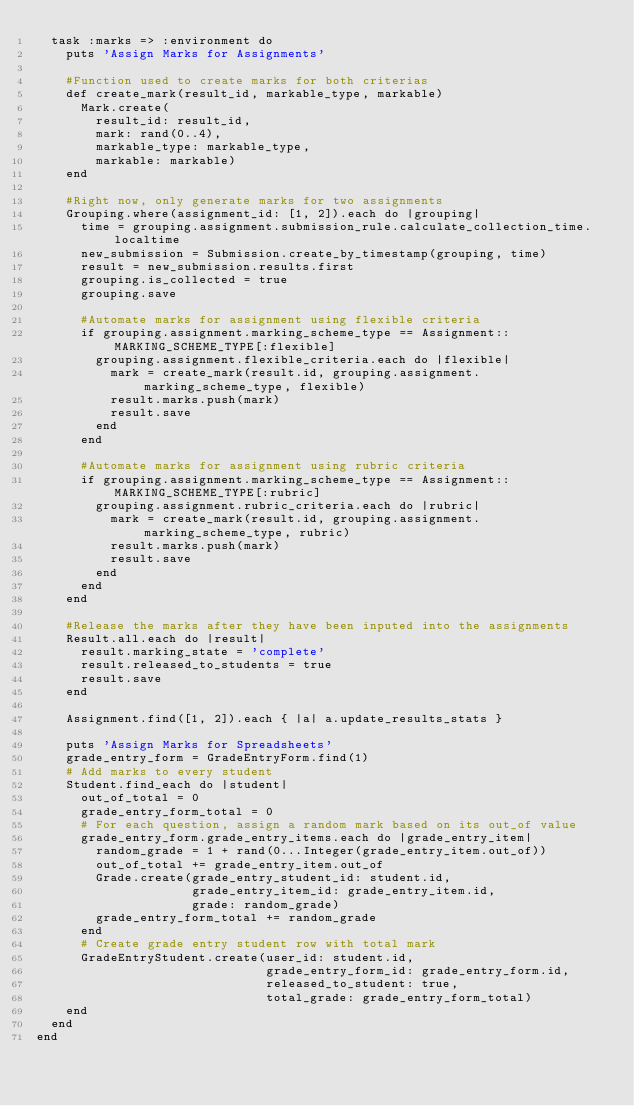Convert code to text. <code><loc_0><loc_0><loc_500><loc_500><_Ruby_>  task :marks => :environment do
    puts 'Assign Marks for Assignments'

    #Function used to create marks for both criterias
    def create_mark(result_id, markable_type, markable)
      Mark.create(
        result_id: result_id,
        mark: rand(0..4),
        markable_type: markable_type,
        markable: markable)
    end

    #Right now, only generate marks for two assignments
    Grouping.where(assignment_id: [1, 2]).each do |grouping|
      time = grouping.assignment.submission_rule.calculate_collection_time.localtime
      new_submission = Submission.create_by_timestamp(grouping, time)
      result = new_submission.results.first
      grouping.is_collected = true
      grouping.save

      #Automate marks for assignment using flexible criteria
      if grouping.assignment.marking_scheme_type == Assignment::MARKING_SCHEME_TYPE[:flexible]
        grouping.assignment.flexible_criteria.each do |flexible|
          mark = create_mark(result.id, grouping.assignment.marking_scheme_type, flexible)
          result.marks.push(mark)
          result.save
        end
      end

      #Automate marks for assignment using rubric criteria
      if grouping.assignment.marking_scheme_type == Assignment::MARKING_SCHEME_TYPE[:rubric]
        grouping.assignment.rubric_criteria.each do |rubric|
          mark = create_mark(result.id, grouping.assignment.marking_scheme_type, rubric)
          result.marks.push(mark)
          result.save
        end
      end
    end

    #Release the marks after they have been inputed into the assignments
    Result.all.each do |result|
      result.marking_state = 'complete'
      result.released_to_students = true
      result.save
    end

    Assignment.find([1, 2]).each { |a| a.update_results_stats }

    puts 'Assign Marks for Spreadsheets'
    grade_entry_form = GradeEntryForm.find(1)
    # Add marks to every student
    Student.find_each do |student|
      out_of_total = 0
      grade_entry_form_total = 0
      # For each question, assign a random mark based on its out_of value
      grade_entry_form.grade_entry_items.each do |grade_entry_item|
        random_grade = 1 + rand(0...Integer(grade_entry_item.out_of))
        out_of_total += grade_entry_item.out_of
        Grade.create(grade_entry_student_id: student.id,
                     grade_entry_item_id: grade_entry_item.id,
                     grade: random_grade)
        grade_entry_form_total += random_grade
      end
      # Create grade entry student row with total mark
      GradeEntryStudent.create(user_id: student.id,
                               grade_entry_form_id: grade_entry_form.id,
                               released_to_student: true,
                               total_grade: grade_entry_form_total)
    end
  end
end
</code> 